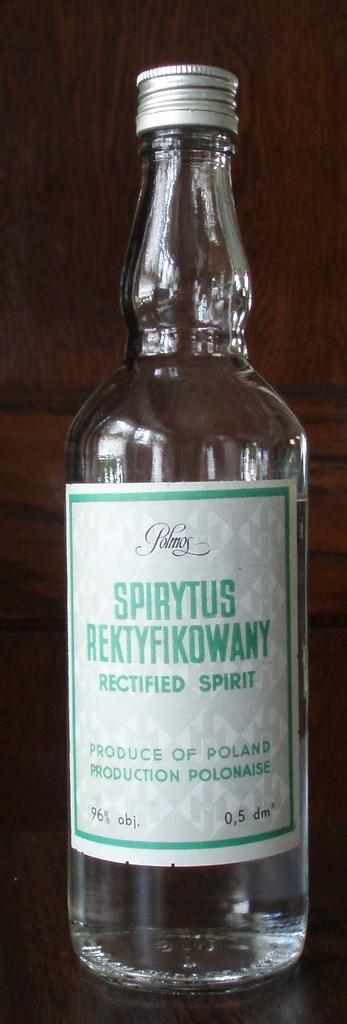<image>
Provide a brief description of the given image. A bottle of Spirytus Rektyfikowany rectified spirit sits on a counter 